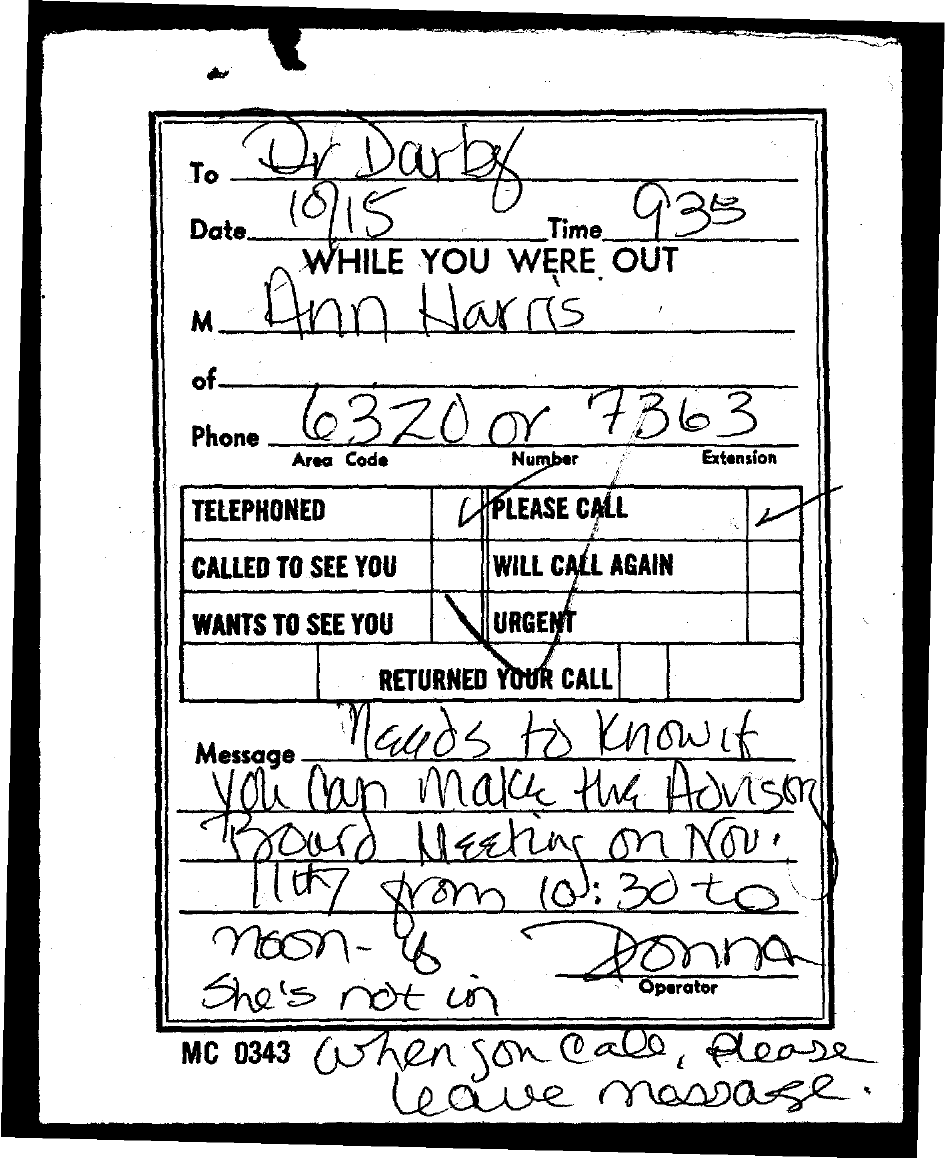To Whom is this message addressed to?
Offer a terse response. Dr Darby. What is the Date?
Ensure brevity in your answer.  10/15. What is the Time?
Make the answer very short. 9.35. Who is this message from?
Offer a terse response. Ann Harris. 